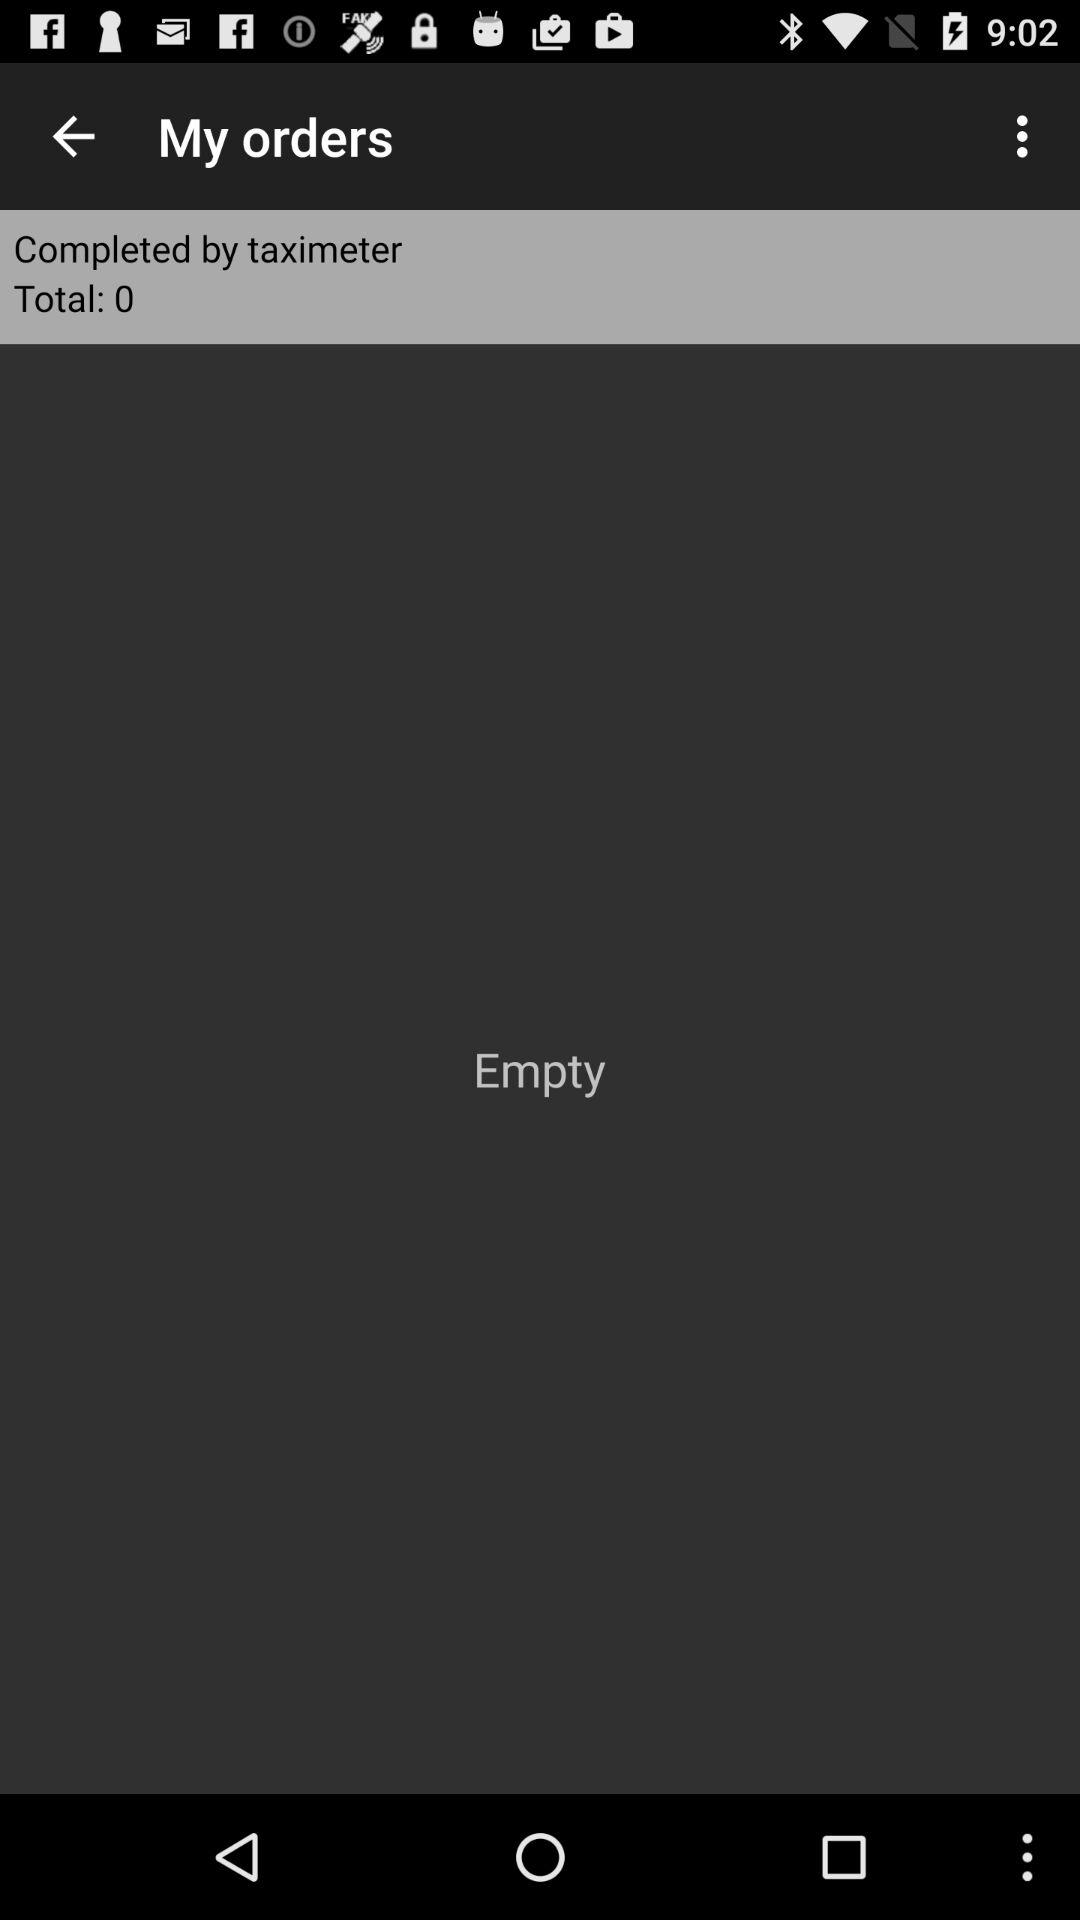What is the name of the application that completed the order? The application name is "taximeter". 